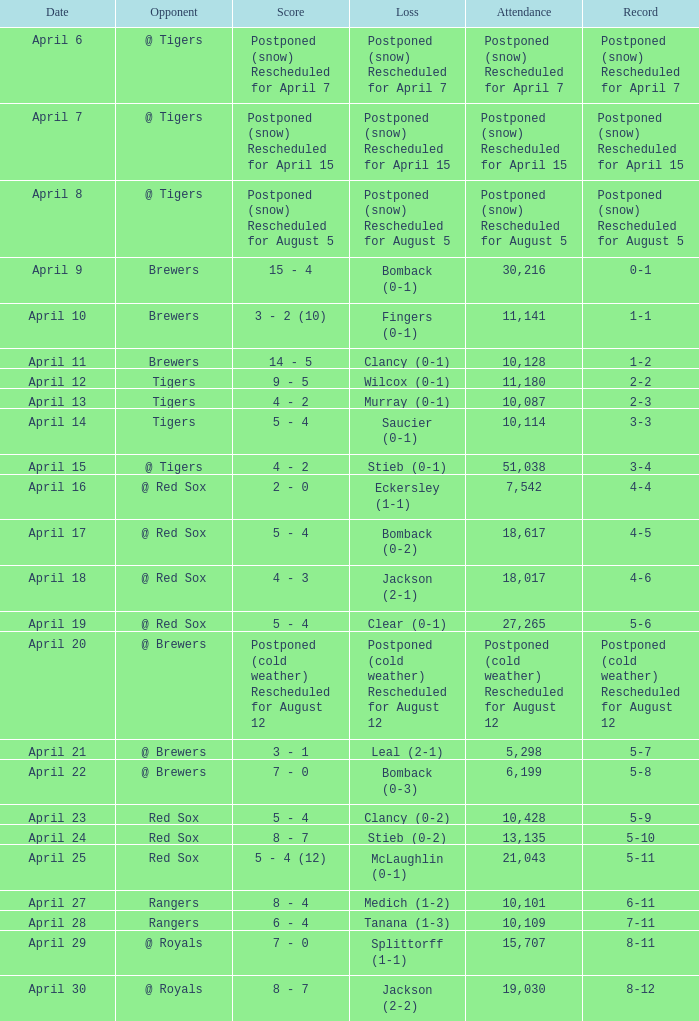What is the record for the game with an attendance of 11,141? 1-1. 